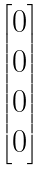<formula> <loc_0><loc_0><loc_500><loc_500>\begin{bmatrix} 0 \\ 0 \\ 0 \\ 0 \end{bmatrix}</formula> 